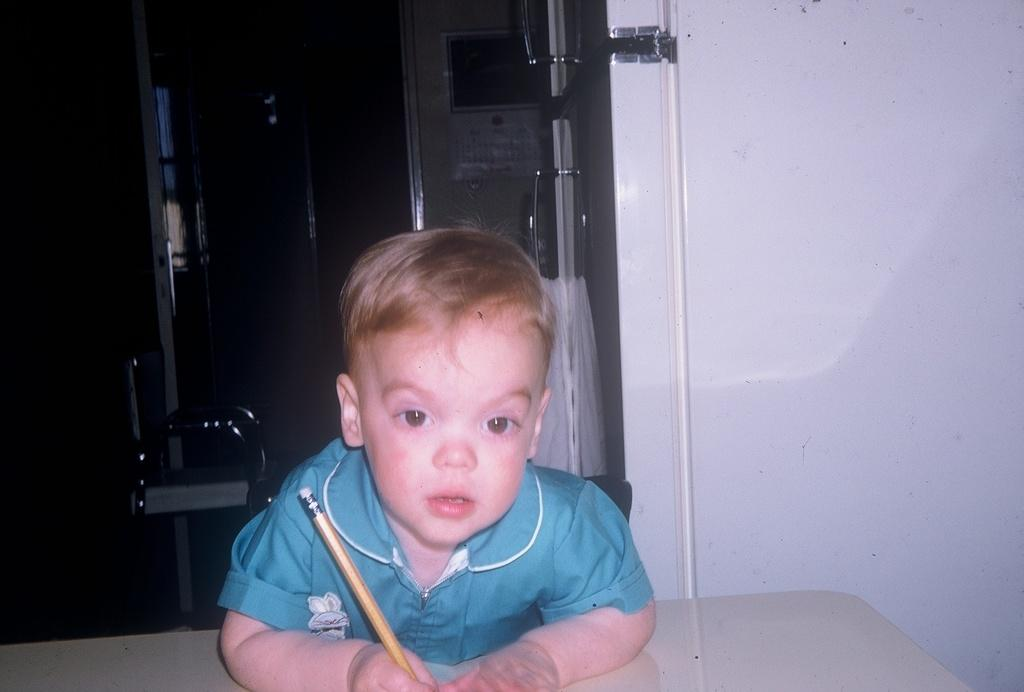What is the main subject of the image? There is a child in the image. What is the child wearing? The child is wearing clothes. What is the child holding in their hand? The child is holding a pencil in their hand. What type of architectural feature can be seen in the image? There is a door in the image. What type of material is present in the image? There is a cloth in the image. What surface is visible in the image? There is a surface in the image. What type of yam is the child eating in the image? There is no yam present in the image; the child is holding a pencil. What sound does the alarm make in the image? There is no alarm present in the image. 